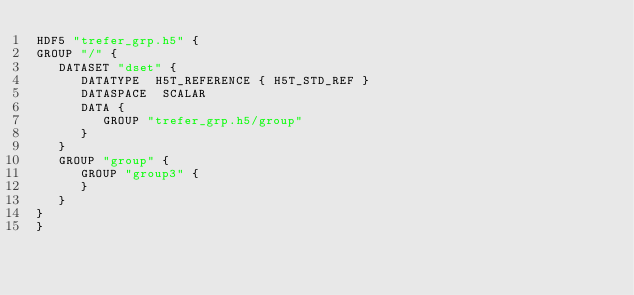Convert code to text. <code><loc_0><loc_0><loc_500><loc_500><_SQL_>HDF5 "trefer_grp.h5" {
GROUP "/" {
   DATASET "dset" {
      DATATYPE  H5T_REFERENCE { H5T_STD_REF }
      DATASPACE  SCALAR
      DATA {
         GROUP "trefer_grp.h5/group"
      }
   }
   GROUP "group" {
      GROUP "group3" {
      }
   }
}
}
</code> 